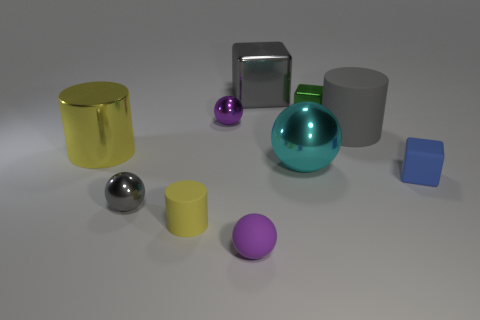Subtract all cubes. How many objects are left? 7 Add 3 cyan spheres. How many cyan spheres are left? 4 Add 7 tiny rubber cylinders. How many tiny rubber cylinders exist? 8 Subtract 0 cyan cubes. How many objects are left? 10 Subtract all large yellow cylinders. Subtract all big metallic cylinders. How many objects are left? 8 